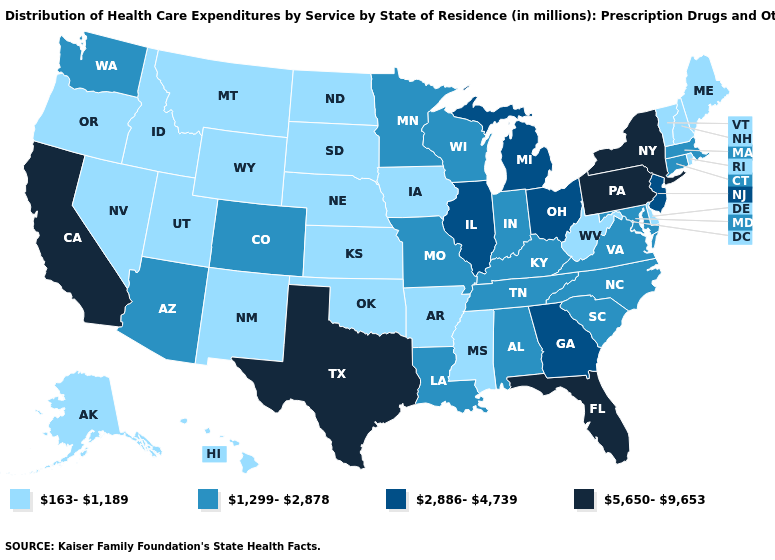Name the states that have a value in the range 2,886-4,739?
Write a very short answer. Georgia, Illinois, Michigan, New Jersey, Ohio. What is the value of Connecticut?
Write a very short answer. 1,299-2,878. What is the value of Mississippi?
Short answer required. 163-1,189. What is the value of Georgia?
Concise answer only. 2,886-4,739. What is the value of Oklahoma?
Answer briefly. 163-1,189. Name the states that have a value in the range 1,299-2,878?
Be succinct. Alabama, Arizona, Colorado, Connecticut, Indiana, Kentucky, Louisiana, Maryland, Massachusetts, Minnesota, Missouri, North Carolina, South Carolina, Tennessee, Virginia, Washington, Wisconsin. What is the highest value in states that border Arkansas?
Keep it brief. 5,650-9,653. Is the legend a continuous bar?
Concise answer only. No. Does Nebraska have the lowest value in the MidWest?
Short answer required. Yes. What is the highest value in the MidWest ?
Concise answer only. 2,886-4,739. What is the value of West Virginia?
Give a very brief answer. 163-1,189. What is the highest value in states that border North Carolina?
Keep it brief. 2,886-4,739. Among the states that border Virginia , does Tennessee have the highest value?
Answer briefly. Yes. What is the value of Wisconsin?
Quick response, please. 1,299-2,878. 